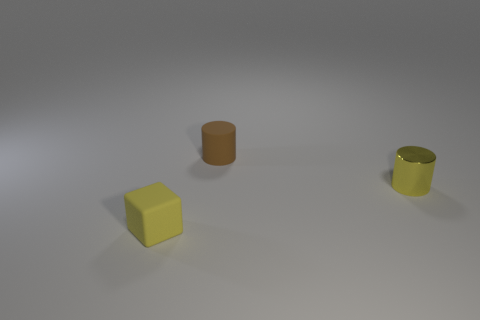Add 2 yellow matte things. How many objects exist? 5 Subtract all blocks. How many objects are left? 2 Add 1 tiny yellow matte objects. How many tiny yellow matte objects are left? 2 Add 1 shiny cylinders. How many shiny cylinders exist? 2 Subtract 1 yellow cylinders. How many objects are left? 2 Subtract all small yellow rubber objects. Subtract all tiny brown cubes. How many objects are left? 2 